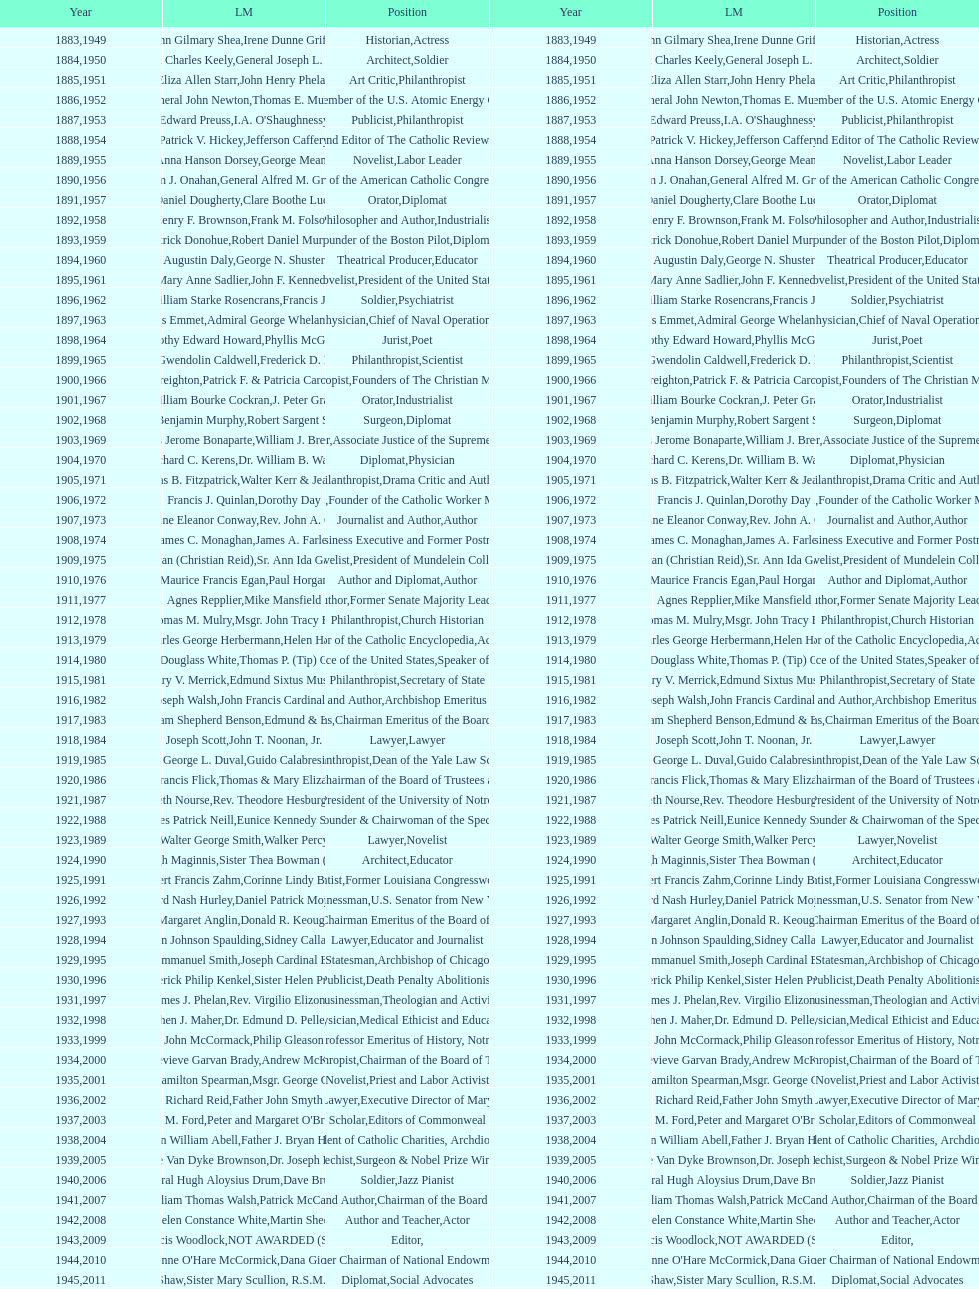What are the number of laetare medalist that held a diplomat position? 8. 